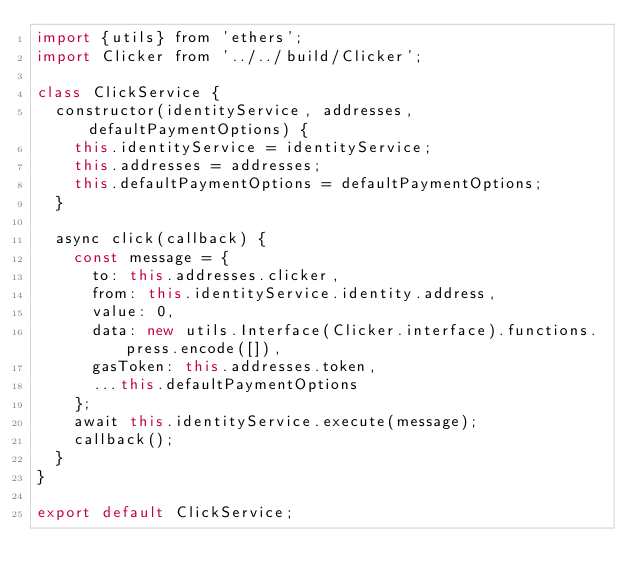<code> <loc_0><loc_0><loc_500><loc_500><_JavaScript_>import {utils} from 'ethers';
import Clicker from '../../build/Clicker';

class ClickService {
  constructor(identityService, addresses, defaultPaymentOptions) {
    this.identityService = identityService;
    this.addresses = addresses;
    this.defaultPaymentOptions = defaultPaymentOptions;
  }

  async click(callback) {
    const message = {
      to: this.addresses.clicker,
      from: this.identityService.identity.address,
      value: 0,
      data: new utils.Interface(Clicker.interface).functions.press.encode([]),
      gasToken: this.addresses.token,
      ...this.defaultPaymentOptions
    };
    await this.identityService.execute(message);
    callback();
  }
}

export default ClickService;
</code> 